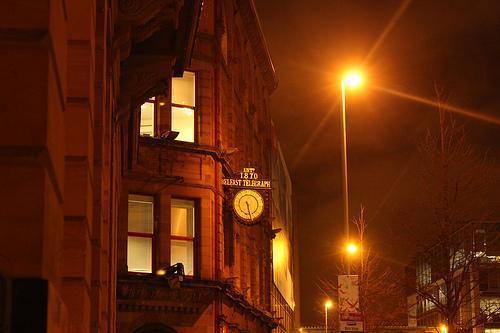How many lights are above the sign?
Give a very brief answer. 1. 